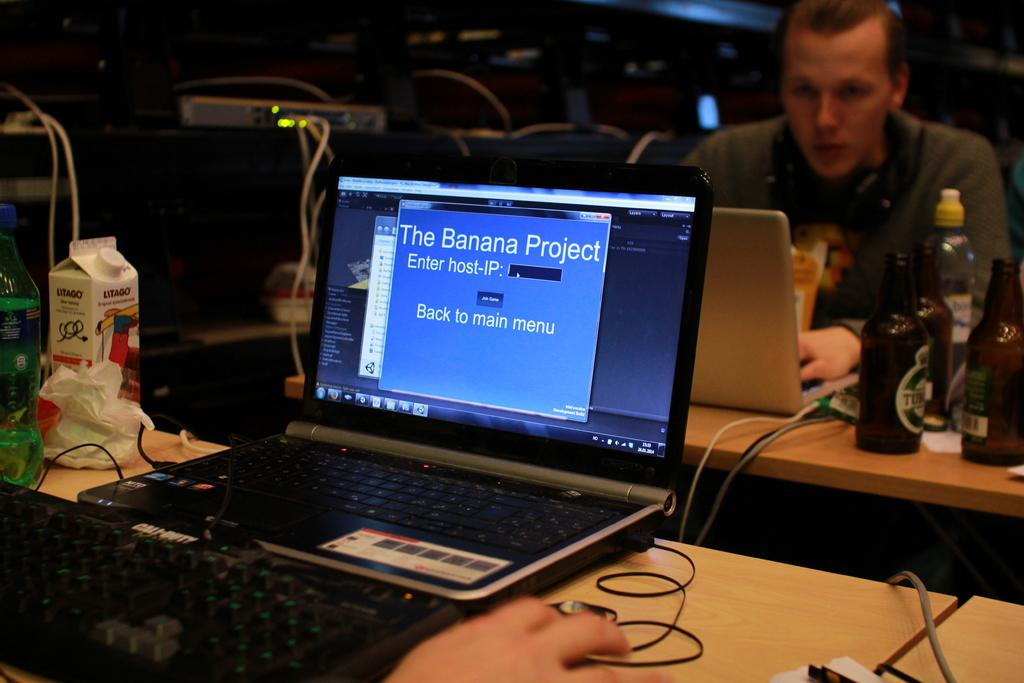Provide a one-sentence caption for the provided image. A laptop is open with a display stating, "The Banana Project.". 